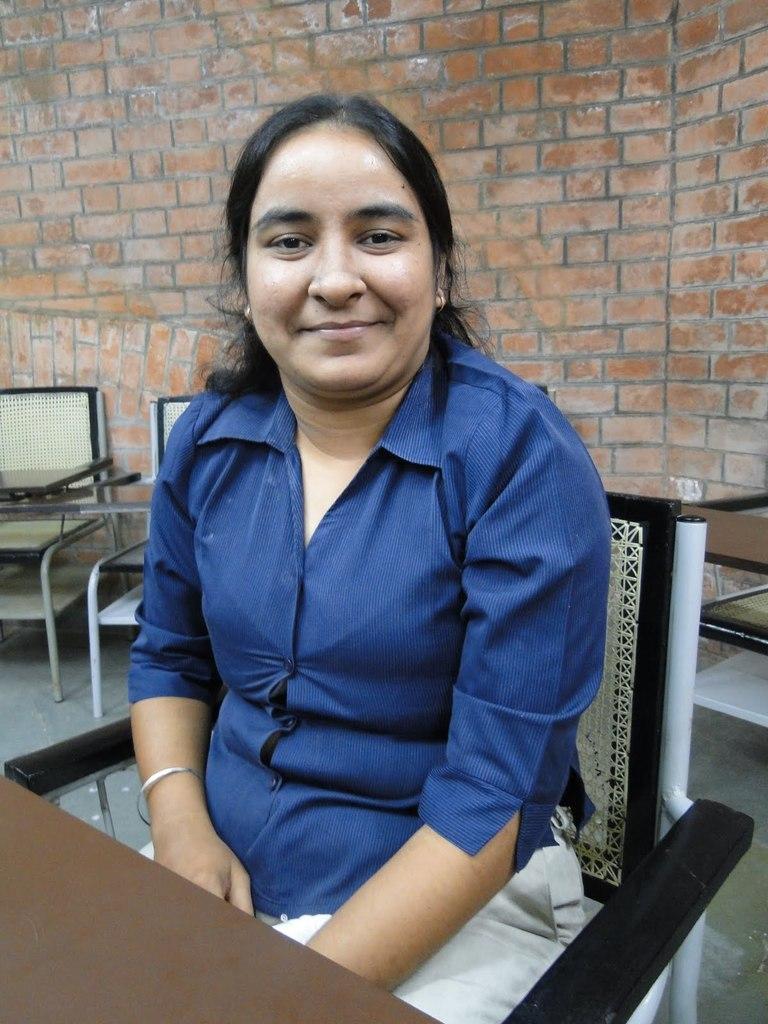How would you summarize this image in a sentence or two? On the background we can see a wall with bricks, few chairs and a table. Here we can see one woman sitting on a chair and she is carrying a pretty smile on her face. 